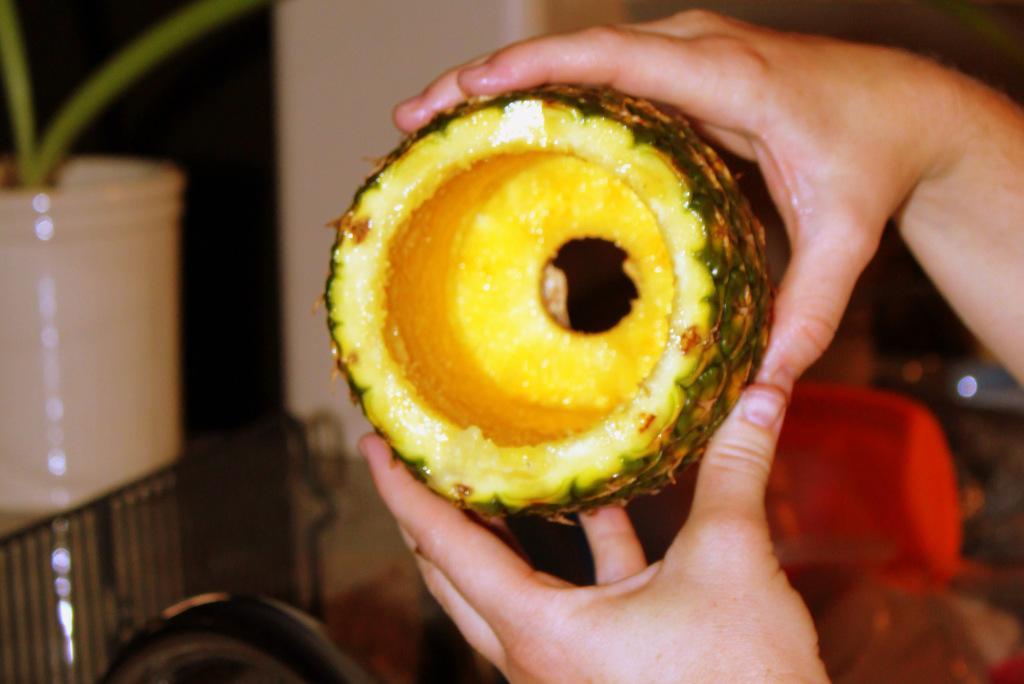Could you give a brief overview of what you see in this image? In this image we can see the hands of a person holding a pineapple. Here we can see a small plant on the left side. 